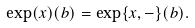Convert formula to latex. <formula><loc_0><loc_0><loc_500><loc_500>\exp ( x ) ( b ) = \exp \{ x , - \} ( b ) .</formula> 